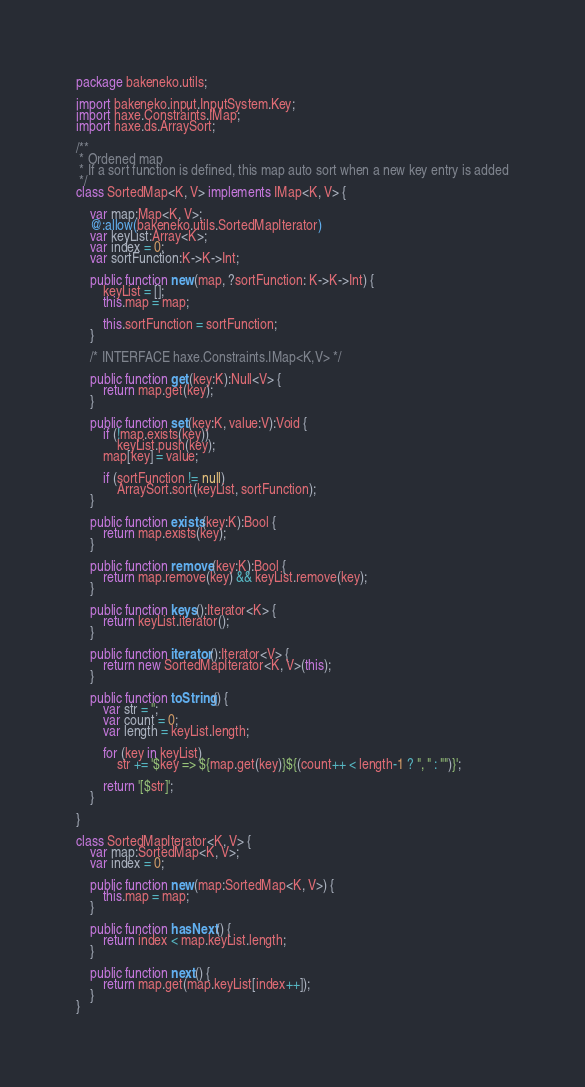Convert code to text. <code><loc_0><loc_0><loc_500><loc_500><_Haxe_>package bakeneko.utils;

import bakeneko.input.InputSystem.Key;
import haxe.Constraints.IMap;
import haxe.ds.ArraySort;

/**
 * Ordened map
 * If a sort function is defined, this map auto sort when a new key entry is added
 */
class SortedMap<K, V> implements IMap<K, V> {

	var map:Map<K, V>;
	@:allow(bakeneko.utils.SortedMapIterator)
	var keyList:Array<K>;
	var index = 0;
	var sortFunction:K->K->Int;
	
	public function new(map, ?sortFunction: K->K->Int) {
		keyList = [];
		this.map = map;
		
		this.sortFunction = sortFunction;
	}
	
	/* INTERFACE haxe.Constraints.IMap<K,V> */
	
	public function get(key:K):Null<V> {
		return map.get(key);
	}
	
	public function set(key:K, value:V):Void {
		if (!map.exists(key))
			keyList.push(key);
		map[key] = value;

		if (sortFunction != null)
			ArraySort.sort(keyList, sortFunction);
	}
	
	public function exists(key:K):Bool {
		return map.exists(key);
	}
	
	public function remove(key:K):Bool {
		return map.remove(key) && keyList.remove(key);
	}
	
	public function keys():Iterator<K> {
		return keyList.iterator();
	}
	
	public function iterator():Iterator<V> {
		return new SortedMapIterator<K, V>(this);
	}
	
	public function toString() {
        var str = '';
		var count = 0;
		var length = keyList.length;
		
        for (key in keyList)
			str += '$key => ${map.get(key)}${(count++ < length-1 ? ", " : "")}';
		
        return '[$str]';
    }
	
}

class SortedMapIterator<K, V> {
	var map:SortedMap<K, V>;
	var index = 0;
	
	public function new(map:SortedMap<K, V>) {
		this.map = map;
	}
	
	public function hasNext() {
		return index < map.keyList.length;
	}
	
	public function next() {
		return map.get(map.keyList[index++]);
	}
}</code> 